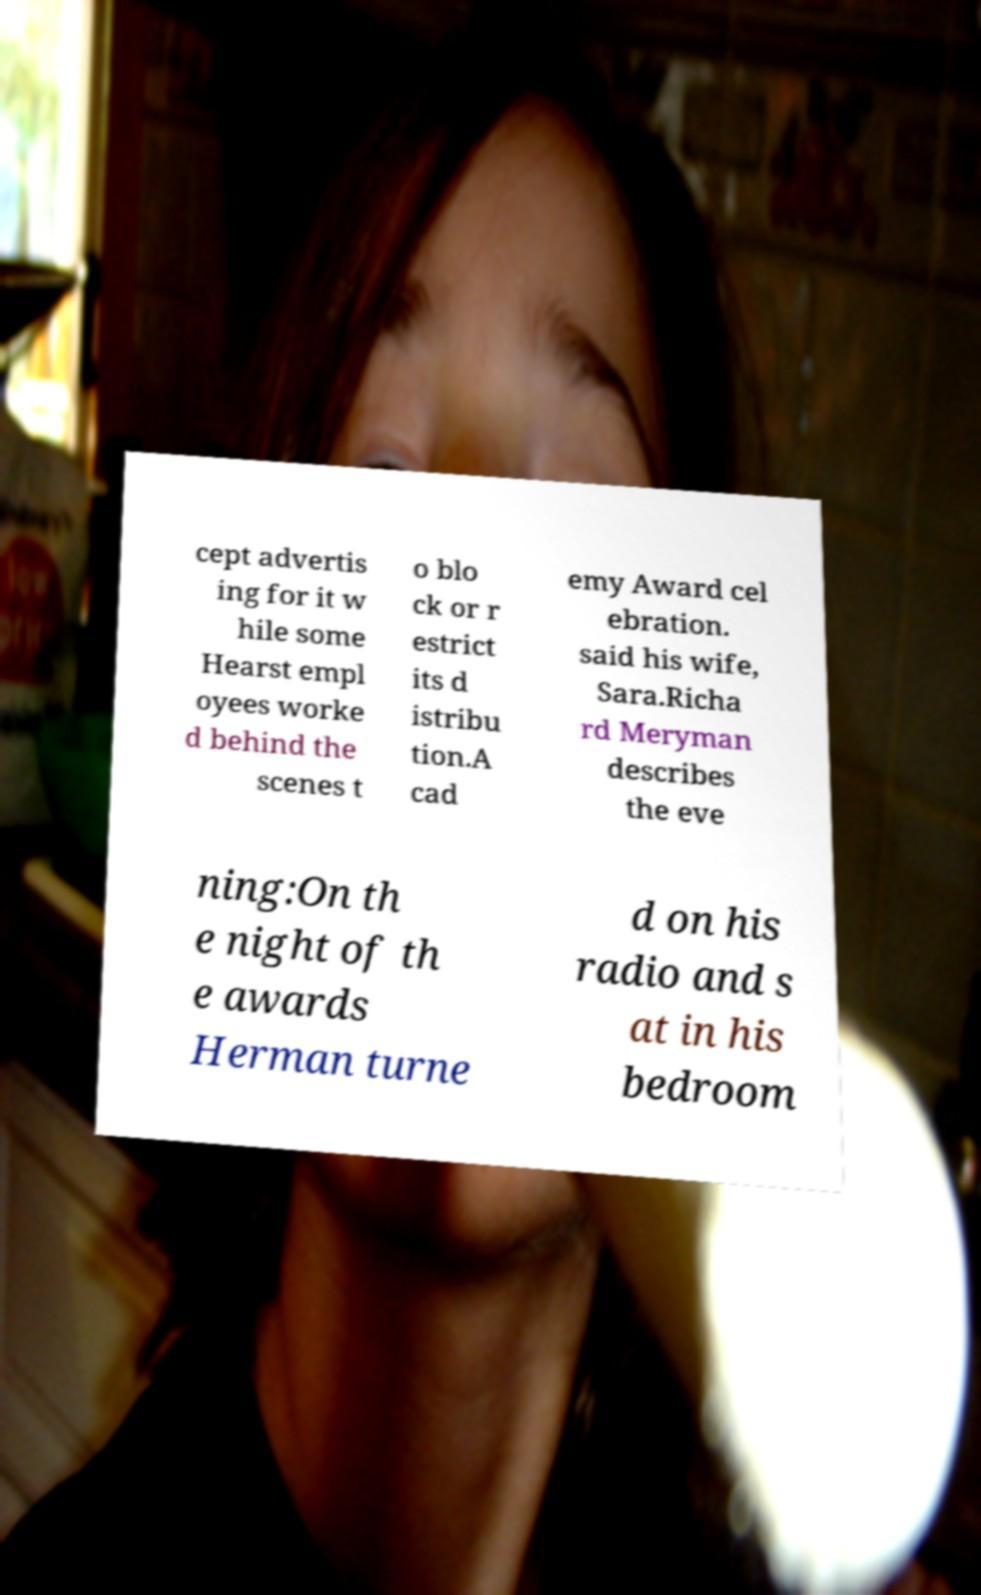There's text embedded in this image that I need extracted. Can you transcribe it verbatim? cept advertis ing for it w hile some Hearst empl oyees worke d behind the scenes t o blo ck or r estrict its d istribu tion.A cad emy Award cel ebration. said his wife, Sara.Richa rd Meryman describes the eve ning:On th e night of th e awards Herman turne d on his radio and s at in his bedroom 